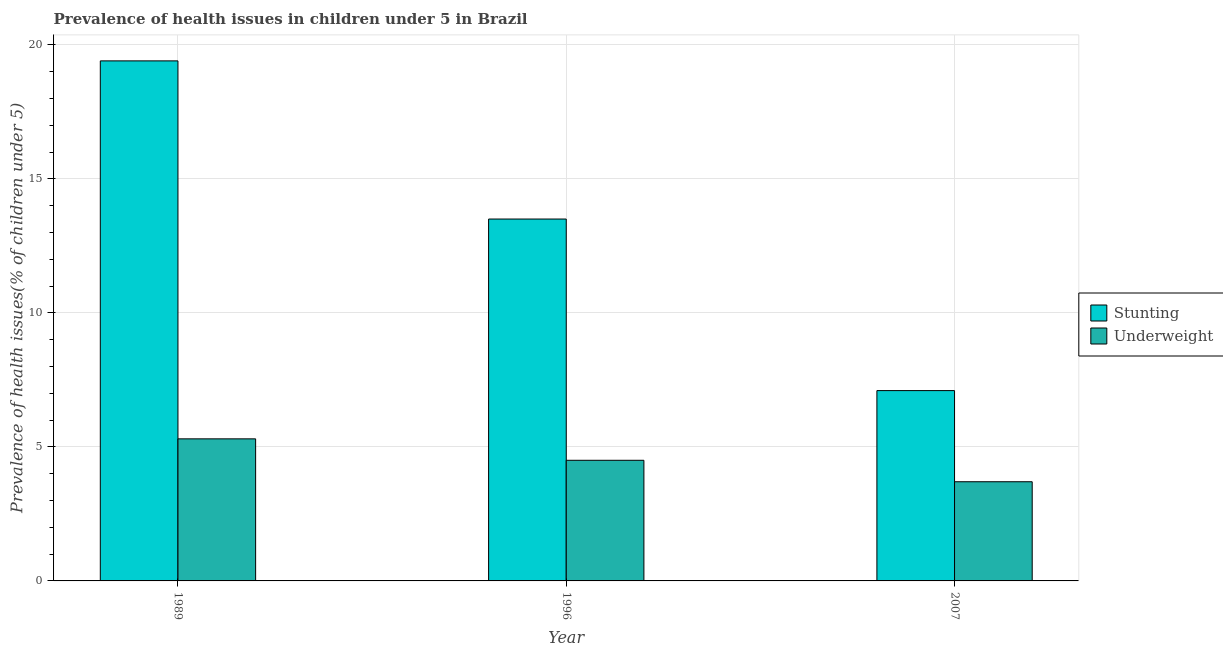How many groups of bars are there?
Ensure brevity in your answer.  3. Are the number of bars per tick equal to the number of legend labels?
Your answer should be compact. Yes. Are the number of bars on each tick of the X-axis equal?
Provide a short and direct response. Yes. What is the percentage of underweight children in 1989?
Keep it short and to the point. 5.3. Across all years, what is the maximum percentage of underweight children?
Provide a short and direct response. 5.3. Across all years, what is the minimum percentage of underweight children?
Your answer should be very brief. 3.7. In which year was the percentage of underweight children minimum?
Ensure brevity in your answer.  2007. What is the total percentage of stunted children in the graph?
Your answer should be compact. 40. What is the difference between the percentage of stunted children in 1989 and that in 1996?
Your answer should be compact. 5.9. What is the difference between the percentage of underweight children in 1996 and the percentage of stunted children in 2007?
Your answer should be very brief. 0.8. What is the average percentage of stunted children per year?
Your answer should be compact. 13.33. In the year 1996, what is the difference between the percentage of underweight children and percentage of stunted children?
Give a very brief answer. 0. In how many years, is the percentage of stunted children greater than 7 %?
Offer a terse response. 3. What is the ratio of the percentage of underweight children in 1989 to that in 2007?
Provide a succinct answer. 1.43. What is the difference between the highest and the second highest percentage of underweight children?
Your answer should be very brief. 0.8. What is the difference between the highest and the lowest percentage of stunted children?
Your answer should be very brief. 12.3. Is the sum of the percentage of stunted children in 1989 and 2007 greater than the maximum percentage of underweight children across all years?
Provide a succinct answer. Yes. What does the 2nd bar from the left in 2007 represents?
Your answer should be very brief. Underweight. What does the 1st bar from the right in 2007 represents?
Your answer should be very brief. Underweight. How many years are there in the graph?
Keep it short and to the point. 3. What is the difference between two consecutive major ticks on the Y-axis?
Provide a short and direct response. 5. Are the values on the major ticks of Y-axis written in scientific E-notation?
Ensure brevity in your answer.  No. Does the graph contain any zero values?
Your answer should be compact. No. Where does the legend appear in the graph?
Offer a very short reply. Center right. How are the legend labels stacked?
Your answer should be compact. Vertical. What is the title of the graph?
Offer a very short reply. Prevalence of health issues in children under 5 in Brazil. Does "Gasoline" appear as one of the legend labels in the graph?
Provide a succinct answer. No. What is the label or title of the X-axis?
Your answer should be very brief. Year. What is the label or title of the Y-axis?
Provide a short and direct response. Prevalence of health issues(% of children under 5). What is the Prevalence of health issues(% of children under 5) in Stunting in 1989?
Ensure brevity in your answer.  19.4. What is the Prevalence of health issues(% of children under 5) of Underweight in 1989?
Offer a very short reply. 5.3. What is the Prevalence of health issues(% of children under 5) in Stunting in 2007?
Offer a terse response. 7.1. What is the Prevalence of health issues(% of children under 5) of Underweight in 2007?
Your answer should be very brief. 3.7. Across all years, what is the maximum Prevalence of health issues(% of children under 5) of Stunting?
Offer a terse response. 19.4. Across all years, what is the maximum Prevalence of health issues(% of children under 5) of Underweight?
Provide a short and direct response. 5.3. Across all years, what is the minimum Prevalence of health issues(% of children under 5) in Stunting?
Offer a terse response. 7.1. Across all years, what is the minimum Prevalence of health issues(% of children under 5) in Underweight?
Ensure brevity in your answer.  3.7. What is the total Prevalence of health issues(% of children under 5) of Stunting in the graph?
Provide a short and direct response. 40. What is the difference between the Prevalence of health issues(% of children under 5) in Stunting in 1989 and that in 1996?
Give a very brief answer. 5.9. What is the difference between the Prevalence of health issues(% of children under 5) of Underweight in 1989 and that in 2007?
Give a very brief answer. 1.6. What is the difference between the Prevalence of health issues(% of children under 5) of Underweight in 1996 and that in 2007?
Your answer should be very brief. 0.8. What is the difference between the Prevalence of health issues(% of children under 5) of Stunting in 1989 and the Prevalence of health issues(% of children under 5) of Underweight in 1996?
Provide a succinct answer. 14.9. What is the average Prevalence of health issues(% of children under 5) in Stunting per year?
Offer a terse response. 13.33. In the year 1989, what is the difference between the Prevalence of health issues(% of children under 5) of Stunting and Prevalence of health issues(% of children under 5) of Underweight?
Offer a very short reply. 14.1. What is the ratio of the Prevalence of health issues(% of children under 5) of Stunting in 1989 to that in 1996?
Provide a succinct answer. 1.44. What is the ratio of the Prevalence of health issues(% of children under 5) of Underweight in 1989 to that in 1996?
Your response must be concise. 1.18. What is the ratio of the Prevalence of health issues(% of children under 5) in Stunting in 1989 to that in 2007?
Make the answer very short. 2.73. What is the ratio of the Prevalence of health issues(% of children under 5) of Underweight in 1989 to that in 2007?
Provide a succinct answer. 1.43. What is the ratio of the Prevalence of health issues(% of children under 5) of Stunting in 1996 to that in 2007?
Your answer should be very brief. 1.9. What is the ratio of the Prevalence of health issues(% of children under 5) of Underweight in 1996 to that in 2007?
Offer a very short reply. 1.22. What is the difference between the highest and the second highest Prevalence of health issues(% of children under 5) of Underweight?
Provide a short and direct response. 0.8. What is the difference between the highest and the lowest Prevalence of health issues(% of children under 5) of Stunting?
Your answer should be very brief. 12.3. 